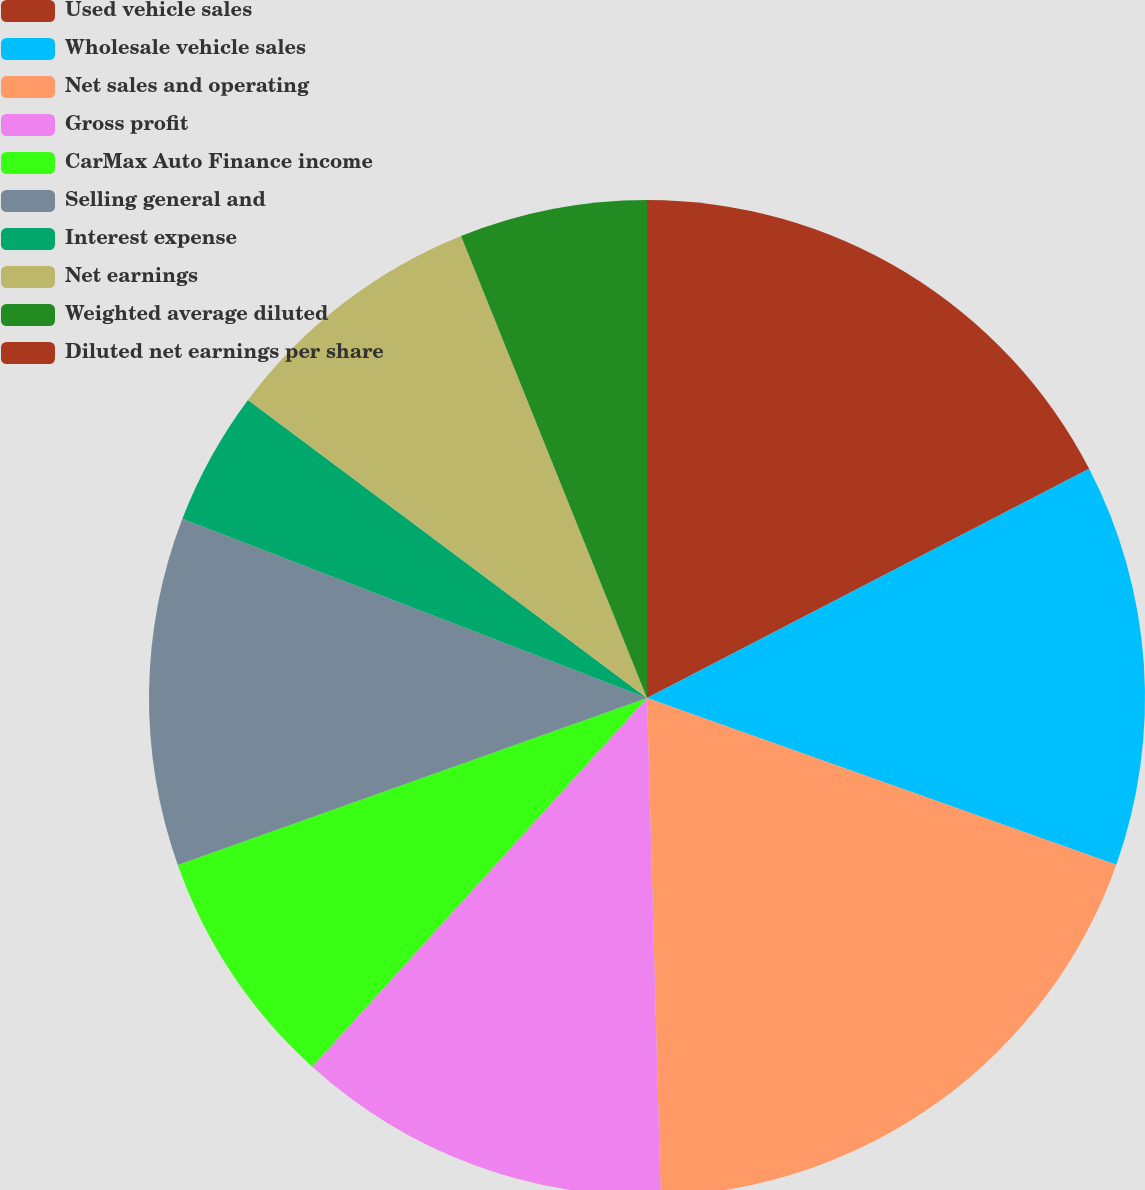Convert chart to OTSL. <chart><loc_0><loc_0><loc_500><loc_500><pie_chart><fcel>Used vehicle sales<fcel>Wholesale vehicle sales<fcel>Net sales and operating<fcel>Gross profit<fcel>CarMax Auto Finance income<fcel>Selling general and<fcel>Interest expense<fcel>Net earnings<fcel>Weighted average diluted<fcel>Diluted net earnings per share<nl><fcel>17.39%<fcel>13.04%<fcel>19.13%<fcel>12.17%<fcel>7.83%<fcel>11.3%<fcel>4.35%<fcel>8.7%<fcel>6.09%<fcel>0.0%<nl></chart> 